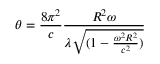<formula> <loc_0><loc_0><loc_500><loc_500>\theta = \frac { 8 \pi ^ { 2 } } { c } \frac { R ^ { 2 } \omega } { \lambda \sqrt { ( 1 - \frac { \omega ^ { 2 } R ^ { 2 } } { c ^ { 2 } } ) } }</formula> 